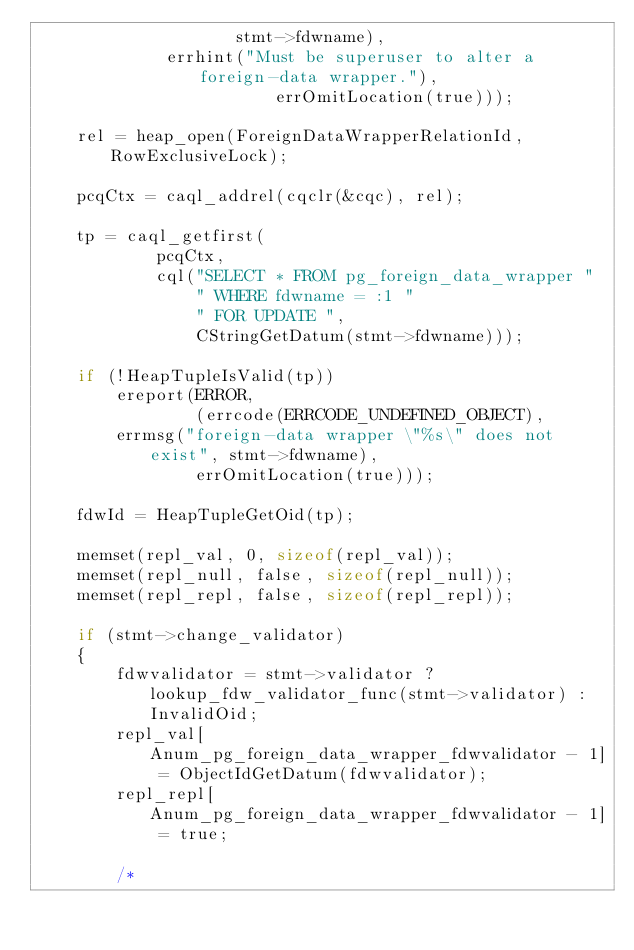Convert code to text. <code><loc_0><loc_0><loc_500><loc_500><_C_>					stmt->fdwname),
			 errhint("Must be superuser to alter a foreign-data wrapper."),
						errOmitLocation(true)));

	rel = heap_open(ForeignDataWrapperRelationId, RowExclusiveLock);

	pcqCtx = caql_addrel(cqclr(&cqc), rel);

	tp = caql_getfirst(
			pcqCtx,
			cql("SELECT * FROM pg_foreign_data_wrapper "
				" WHERE fdwname = :1 "
				" FOR UPDATE ",
				CStringGetDatum(stmt->fdwname)));

	if (!HeapTupleIsValid(tp))
		ereport(ERROR,
				(errcode(ERRCODE_UNDEFINED_OBJECT),
		errmsg("foreign-data wrapper \"%s\" does not exist", stmt->fdwname),
				errOmitLocation(true)));

	fdwId = HeapTupleGetOid(tp);

	memset(repl_val, 0, sizeof(repl_val));
	memset(repl_null, false, sizeof(repl_null));
	memset(repl_repl, false, sizeof(repl_repl));

	if (stmt->change_validator)
	{
		fdwvalidator = stmt->validator ? lookup_fdw_validator_func(stmt->validator) : InvalidOid;
		repl_val[Anum_pg_foreign_data_wrapper_fdwvalidator - 1] = ObjectIdGetDatum(fdwvalidator);
		repl_repl[Anum_pg_foreign_data_wrapper_fdwvalidator - 1] = true;

		/*</code> 